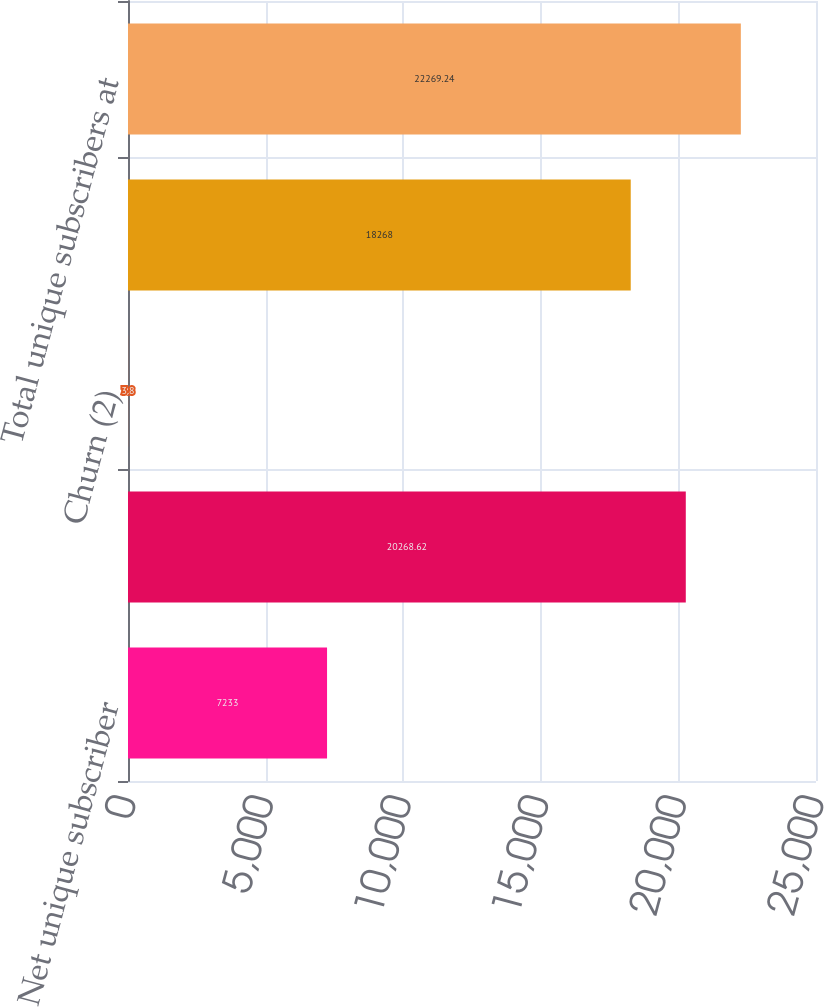Convert chart to OTSL. <chart><loc_0><loc_0><loc_500><loc_500><bar_chart><fcel>Net unique subscriber<fcel>Total domestic unique<fcel>Churn (2)<fcel>Paid unique subscribers at end<fcel>Total unique subscribers at<nl><fcel>7233<fcel>20268.6<fcel>3.8<fcel>18268<fcel>22269.2<nl></chart> 